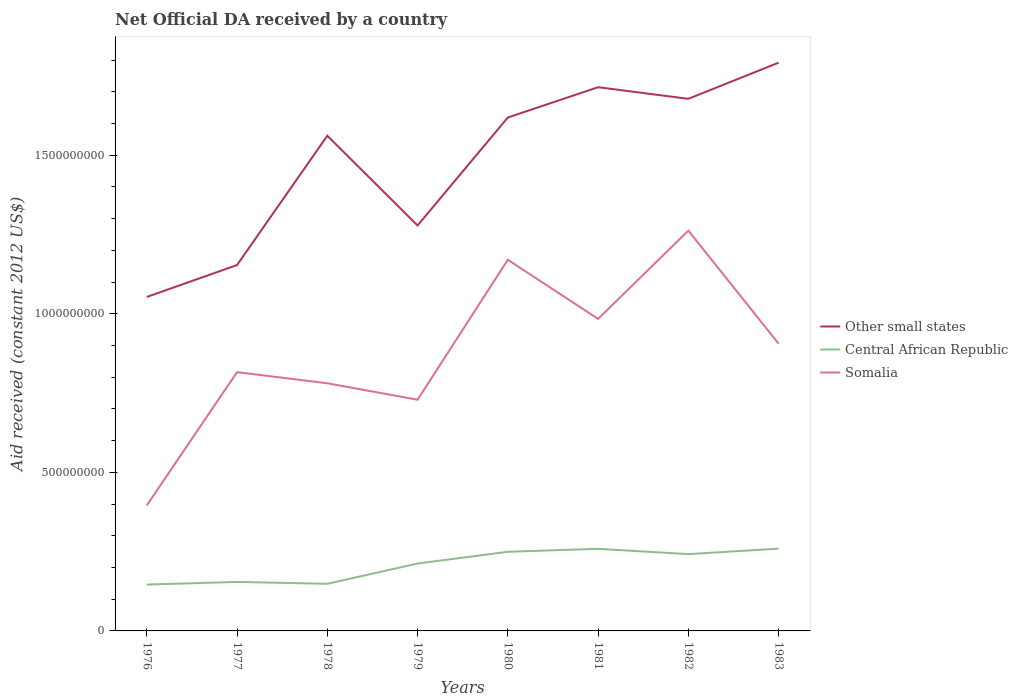Does the line corresponding to Somalia intersect with the line corresponding to Central African Republic?
Keep it short and to the point. No. Is the number of lines equal to the number of legend labels?
Make the answer very short. Yes. Across all years, what is the maximum net official development assistance aid received in Other small states?
Make the answer very short. 1.05e+09. In which year was the net official development assistance aid received in Somalia maximum?
Offer a very short reply. 1976. What is the total net official development assistance aid received in Somalia in the graph?
Offer a very short reply. -4.20e+08. What is the difference between the highest and the second highest net official development assistance aid received in Somalia?
Your answer should be very brief. 8.66e+08. What is the difference between the highest and the lowest net official development assistance aid received in Other small states?
Give a very brief answer. 5. Is the net official development assistance aid received in Somalia strictly greater than the net official development assistance aid received in Central African Republic over the years?
Your response must be concise. No. How many years are there in the graph?
Provide a succinct answer. 8. What is the difference between two consecutive major ticks on the Y-axis?
Offer a terse response. 5.00e+08. Are the values on the major ticks of Y-axis written in scientific E-notation?
Provide a short and direct response. No. Does the graph contain any zero values?
Provide a short and direct response. No. What is the title of the graph?
Provide a succinct answer. Net Official DA received by a country. What is the label or title of the Y-axis?
Give a very brief answer. Aid received (constant 2012 US$). What is the Aid received (constant 2012 US$) in Other small states in 1976?
Provide a succinct answer. 1.05e+09. What is the Aid received (constant 2012 US$) in Central African Republic in 1976?
Offer a terse response. 1.46e+08. What is the Aid received (constant 2012 US$) of Somalia in 1976?
Offer a terse response. 3.96e+08. What is the Aid received (constant 2012 US$) of Other small states in 1977?
Give a very brief answer. 1.15e+09. What is the Aid received (constant 2012 US$) in Central African Republic in 1977?
Give a very brief answer. 1.54e+08. What is the Aid received (constant 2012 US$) in Somalia in 1977?
Keep it short and to the point. 8.16e+08. What is the Aid received (constant 2012 US$) in Other small states in 1978?
Give a very brief answer. 1.56e+09. What is the Aid received (constant 2012 US$) of Central African Republic in 1978?
Provide a short and direct response. 1.49e+08. What is the Aid received (constant 2012 US$) in Somalia in 1978?
Give a very brief answer. 7.81e+08. What is the Aid received (constant 2012 US$) of Other small states in 1979?
Provide a short and direct response. 1.28e+09. What is the Aid received (constant 2012 US$) of Central African Republic in 1979?
Give a very brief answer. 2.12e+08. What is the Aid received (constant 2012 US$) of Somalia in 1979?
Provide a short and direct response. 7.29e+08. What is the Aid received (constant 2012 US$) in Other small states in 1980?
Offer a terse response. 1.62e+09. What is the Aid received (constant 2012 US$) of Central African Republic in 1980?
Your answer should be compact. 2.50e+08. What is the Aid received (constant 2012 US$) of Somalia in 1980?
Keep it short and to the point. 1.17e+09. What is the Aid received (constant 2012 US$) in Other small states in 1981?
Provide a short and direct response. 1.71e+09. What is the Aid received (constant 2012 US$) in Central African Republic in 1981?
Your answer should be very brief. 2.59e+08. What is the Aid received (constant 2012 US$) of Somalia in 1981?
Your answer should be very brief. 9.84e+08. What is the Aid received (constant 2012 US$) in Other small states in 1982?
Your answer should be compact. 1.68e+09. What is the Aid received (constant 2012 US$) of Central African Republic in 1982?
Offer a terse response. 2.42e+08. What is the Aid received (constant 2012 US$) in Somalia in 1982?
Offer a very short reply. 1.26e+09. What is the Aid received (constant 2012 US$) in Other small states in 1983?
Ensure brevity in your answer.  1.79e+09. What is the Aid received (constant 2012 US$) in Central African Republic in 1983?
Provide a succinct answer. 2.59e+08. What is the Aid received (constant 2012 US$) in Somalia in 1983?
Offer a very short reply. 9.06e+08. Across all years, what is the maximum Aid received (constant 2012 US$) of Other small states?
Make the answer very short. 1.79e+09. Across all years, what is the maximum Aid received (constant 2012 US$) in Central African Republic?
Your answer should be very brief. 2.59e+08. Across all years, what is the maximum Aid received (constant 2012 US$) in Somalia?
Make the answer very short. 1.26e+09. Across all years, what is the minimum Aid received (constant 2012 US$) of Other small states?
Your response must be concise. 1.05e+09. Across all years, what is the minimum Aid received (constant 2012 US$) of Central African Republic?
Offer a very short reply. 1.46e+08. Across all years, what is the minimum Aid received (constant 2012 US$) in Somalia?
Offer a terse response. 3.96e+08. What is the total Aid received (constant 2012 US$) in Other small states in the graph?
Keep it short and to the point. 1.18e+1. What is the total Aid received (constant 2012 US$) in Central African Republic in the graph?
Offer a terse response. 1.67e+09. What is the total Aid received (constant 2012 US$) of Somalia in the graph?
Provide a short and direct response. 7.04e+09. What is the difference between the Aid received (constant 2012 US$) of Other small states in 1976 and that in 1977?
Your answer should be very brief. -1.00e+08. What is the difference between the Aid received (constant 2012 US$) in Central African Republic in 1976 and that in 1977?
Provide a succinct answer. -8.35e+06. What is the difference between the Aid received (constant 2012 US$) of Somalia in 1976 and that in 1977?
Make the answer very short. -4.20e+08. What is the difference between the Aid received (constant 2012 US$) in Other small states in 1976 and that in 1978?
Your answer should be very brief. -5.08e+08. What is the difference between the Aid received (constant 2012 US$) of Central African Republic in 1976 and that in 1978?
Give a very brief answer. -2.46e+06. What is the difference between the Aid received (constant 2012 US$) of Somalia in 1976 and that in 1978?
Keep it short and to the point. -3.85e+08. What is the difference between the Aid received (constant 2012 US$) of Other small states in 1976 and that in 1979?
Keep it short and to the point. -2.25e+08. What is the difference between the Aid received (constant 2012 US$) of Central African Republic in 1976 and that in 1979?
Your answer should be very brief. -6.63e+07. What is the difference between the Aid received (constant 2012 US$) in Somalia in 1976 and that in 1979?
Offer a very short reply. -3.33e+08. What is the difference between the Aid received (constant 2012 US$) of Other small states in 1976 and that in 1980?
Make the answer very short. -5.66e+08. What is the difference between the Aid received (constant 2012 US$) in Central African Republic in 1976 and that in 1980?
Keep it short and to the point. -1.03e+08. What is the difference between the Aid received (constant 2012 US$) of Somalia in 1976 and that in 1980?
Provide a short and direct response. -7.75e+08. What is the difference between the Aid received (constant 2012 US$) in Other small states in 1976 and that in 1981?
Provide a short and direct response. -6.61e+08. What is the difference between the Aid received (constant 2012 US$) in Central African Republic in 1976 and that in 1981?
Your answer should be very brief. -1.13e+08. What is the difference between the Aid received (constant 2012 US$) of Somalia in 1976 and that in 1981?
Provide a short and direct response. -5.88e+08. What is the difference between the Aid received (constant 2012 US$) in Other small states in 1976 and that in 1982?
Your response must be concise. -6.25e+08. What is the difference between the Aid received (constant 2012 US$) of Central African Republic in 1976 and that in 1982?
Your answer should be very brief. -9.60e+07. What is the difference between the Aid received (constant 2012 US$) of Somalia in 1976 and that in 1982?
Offer a terse response. -8.66e+08. What is the difference between the Aid received (constant 2012 US$) of Other small states in 1976 and that in 1983?
Ensure brevity in your answer.  -7.39e+08. What is the difference between the Aid received (constant 2012 US$) of Central African Republic in 1976 and that in 1983?
Your answer should be very brief. -1.13e+08. What is the difference between the Aid received (constant 2012 US$) of Somalia in 1976 and that in 1983?
Provide a short and direct response. -5.10e+08. What is the difference between the Aid received (constant 2012 US$) in Other small states in 1977 and that in 1978?
Your answer should be compact. -4.08e+08. What is the difference between the Aid received (constant 2012 US$) of Central African Republic in 1977 and that in 1978?
Make the answer very short. 5.89e+06. What is the difference between the Aid received (constant 2012 US$) of Somalia in 1977 and that in 1978?
Make the answer very short. 3.50e+07. What is the difference between the Aid received (constant 2012 US$) in Other small states in 1977 and that in 1979?
Your answer should be very brief. -1.25e+08. What is the difference between the Aid received (constant 2012 US$) of Central African Republic in 1977 and that in 1979?
Your answer should be compact. -5.80e+07. What is the difference between the Aid received (constant 2012 US$) in Somalia in 1977 and that in 1979?
Make the answer very short. 8.69e+07. What is the difference between the Aid received (constant 2012 US$) of Other small states in 1977 and that in 1980?
Your answer should be very brief. -4.65e+08. What is the difference between the Aid received (constant 2012 US$) in Central African Republic in 1977 and that in 1980?
Your response must be concise. -9.50e+07. What is the difference between the Aid received (constant 2012 US$) of Somalia in 1977 and that in 1980?
Your response must be concise. -3.54e+08. What is the difference between the Aid received (constant 2012 US$) of Other small states in 1977 and that in 1981?
Offer a very short reply. -5.61e+08. What is the difference between the Aid received (constant 2012 US$) in Central African Republic in 1977 and that in 1981?
Ensure brevity in your answer.  -1.04e+08. What is the difference between the Aid received (constant 2012 US$) in Somalia in 1977 and that in 1981?
Keep it short and to the point. -1.68e+08. What is the difference between the Aid received (constant 2012 US$) in Other small states in 1977 and that in 1982?
Your answer should be very brief. -5.24e+08. What is the difference between the Aid received (constant 2012 US$) in Central African Republic in 1977 and that in 1982?
Your answer should be compact. -8.76e+07. What is the difference between the Aid received (constant 2012 US$) of Somalia in 1977 and that in 1982?
Keep it short and to the point. -4.46e+08. What is the difference between the Aid received (constant 2012 US$) of Other small states in 1977 and that in 1983?
Provide a short and direct response. -6.38e+08. What is the difference between the Aid received (constant 2012 US$) in Central African Republic in 1977 and that in 1983?
Make the answer very short. -1.05e+08. What is the difference between the Aid received (constant 2012 US$) in Somalia in 1977 and that in 1983?
Your response must be concise. -8.97e+07. What is the difference between the Aid received (constant 2012 US$) in Other small states in 1978 and that in 1979?
Make the answer very short. 2.83e+08. What is the difference between the Aid received (constant 2012 US$) of Central African Republic in 1978 and that in 1979?
Offer a very short reply. -6.39e+07. What is the difference between the Aid received (constant 2012 US$) of Somalia in 1978 and that in 1979?
Provide a succinct answer. 5.19e+07. What is the difference between the Aid received (constant 2012 US$) in Other small states in 1978 and that in 1980?
Keep it short and to the point. -5.75e+07. What is the difference between the Aid received (constant 2012 US$) of Central African Republic in 1978 and that in 1980?
Ensure brevity in your answer.  -1.01e+08. What is the difference between the Aid received (constant 2012 US$) in Somalia in 1978 and that in 1980?
Provide a succinct answer. -3.89e+08. What is the difference between the Aid received (constant 2012 US$) of Other small states in 1978 and that in 1981?
Offer a terse response. -1.53e+08. What is the difference between the Aid received (constant 2012 US$) of Central African Republic in 1978 and that in 1981?
Offer a terse response. -1.10e+08. What is the difference between the Aid received (constant 2012 US$) of Somalia in 1978 and that in 1981?
Offer a very short reply. -2.03e+08. What is the difference between the Aid received (constant 2012 US$) of Other small states in 1978 and that in 1982?
Keep it short and to the point. -1.16e+08. What is the difference between the Aid received (constant 2012 US$) in Central African Republic in 1978 and that in 1982?
Your answer should be compact. -9.35e+07. What is the difference between the Aid received (constant 2012 US$) of Somalia in 1978 and that in 1982?
Offer a very short reply. -4.81e+08. What is the difference between the Aid received (constant 2012 US$) in Other small states in 1978 and that in 1983?
Offer a terse response. -2.30e+08. What is the difference between the Aid received (constant 2012 US$) of Central African Republic in 1978 and that in 1983?
Provide a succinct answer. -1.11e+08. What is the difference between the Aid received (constant 2012 US$) of Somalia in 1978 and that in 1983?
Your answer should be very brief. -1.25e+08. What is the difference between the Aid received (constant 2012 US$) of Other small states in 1979 and that in 1980?
Make the answer very short. -3.40e+08. What is the difference between the Aid received (constant 2012 US$) in Central African Republic in 1979 and that in 1980?
Ensure brevity in your answer.  -3.70e+07. What is the difference between the Aid received (constant 2012 US$) in Somalia in 1979 and that in 1980?
Your answer should be compact. -4.41e+08. What is the difference between the Aid received (constant 2012 US$) in Other small states in 1979 and that in 1981?
Provide a succinct answer. -4.36e+08. What is the difference between the Aid received (constant 2012 US$) of Central African Republic in 1979 and that in 1981?
Give a very brief answer. -4.64e+07. What is the difference between the Aid received (constant 2012 US$) in Somalia in 1979 and that in 1981?
Your response must be concise. -2.55e+08. What is the difference between the Aid received (constant 2012 US$) of Other small states in 1979 and that in 1982?
Make the answer very short. -3.99e+08. What is the difference between the Aid received (constant 2012 US$) in Central African Republic in 1979 and that in 1982?
Your response must be concise. -2.96e+07. What is the difference between the Aid received (constant 2012 US$) in Somalia in 1979 and that in 1982?
Your answer should be compact. -5.33e+08. What is the difference between the Aid received (constant 2012 US$) of Other small states in 1979 and that in 1983?
Offer a terse response. -5.13e+08. What is the difference between the Aid received (constant 2012 US$) in Central African Republic in 1979 and that in 1983?
Provide a succinct answer. -4.69e+07. What is the difference between the Aid received (constant 2012 US$) in Somalia in 1979 and that in 1983?
Provide a short and direct response. -1.77e+08. What is the difference between the Aid received (constant 2012 US$) of Other small states in 1980 and that in 1981?
Your answer should be compact. -9.55e+07. What is the difference between the Aid received (constant 2012 US$) in Central African Republic in 1980 and that in 1981?
Your answer should be very brief. -9.37e+06. What is the difference between the Aid received (constant 2012 US$) in Somalia in 1980 and that in 1981?
Your answer should be compact. 1.87e+08. What is the difference between the Aid received (constant 2012 US$) in Other small states in 1980 and that in 1982?
Offer a very short reply. -5.89e+07. What is the difference between the Aid received (constant 2012 US$) in Central African Republic in 1980 and that in 1982?
Your answer should be very brief. 7.39e+06. What is the difference between the Aid received (constant 2012 US$) in Somalia in 1980 and that in 1982?
Ensure brevity in your answer.  -9.18e+07. What is the difference between the Aid received (constant 2012 US$) of Other small states in 1980 and that in 1983?
Provide a short and direct response. -1.73e+08. What is the difference between the Aid received (constant 2012 US$) of Central African Republic in 1980 and that in 1983?
Provide a succinct answer. -9.90e+06. What is the difference between the Aid received (constant 2012 US$) of Somalia in 1980 and that in 1983?
Your response must be concise. 2.65e+08. What is the difference between the Aid received (constant 2012 US$) of Other small states in 1981 and that in 1982?
Provide a succinct answer. 3.66e+07. What is the difference between the Aid received (constant 2012 US$) in Central African Republic in 1981 and that in 1982?
Make the answer very short. 1.68e+07. What is the difference between the Aid received (constant 2012 US$) in Somalia in 1981 and that in 1982?
Your answer should be compact. -2.78e+08. What is the difference between the Aid received (constant 2012 US$) of Other small states in 1981 and that in 1983?
Make the answer very short. -7.74e+07. What is the difference between the Aid received (constant 2012 US$) in Central African Republic in 1981 and that in 1983?
Provide a short and direct response. -5.30e+05. What is the difference between the Aid received (constant 2012 US$) of Somalia in 1981 and that in 1983?
Your response must be concise. 7.82e+07. What is the difference between the Aid received (constant 2012 US$) in Other small states in 1982 and that in 1983?
Your response must be concise. -1.14e+08. What is the difference between the Aid received (constant 2012 US$) in Central African Republic in 1982 and that in 1983?
Ensure brevity in your answer.  -1.73e+07. What is the difference between the Aid received (constant 2012 US$) of Somalia in 1982 and that in 1983?
Offer a very short reply. 3.57e+08. What is the difference between the Aid received (constant 2012 US$) of Other small states in 1976 and the Aid received (constant 2012 US$) of Central African Republic in 1977?
Make the answer very short. 8.99e+08. What is the difference between the Aid received (constant 2012 US$) of Other small states in 1976 and the Aid received (constant 2012 US$) of Somalia in 1977?
Ensure brevity in your answer.  2.37e+08. What is the difference between the Aid received (constant 2012 US$) of Central African Republic in 1976 and the Aid received (constant 2012 US$) of Somalia in 1977?
Provide a short and direct response. -6.70e+08. What is the difference between the Aid received (constant 2012 US$) of Other small states in 1976 and the Aid received (constant 2012 US$) of Central African Republic in 1978?
Keep it short and to the point. 9.04e+08. What is the difference between the Aid received (constant 2012 US$) in Other small states in 1976 and the Aid received (constant 2012 US$) in Somalia in 1978?
Your answer should be compact. 2.72e+08. What is the difference between the Aid received (constant 2012 US$) in Central African Republic in 1976 and the Aid received (constant 2012 US$) in Somalia in 1978?
Keep it short and to the point. -6.35e+08. What is the difference between the Aid received (constant 2012 US$) in Other small states in 1976 and the Aid received (constant 2012 US$) in Central African Republic in 1979?
Keep it short and to the point. 8.41e+08. What is the difference between the Aid received (constant 2012 US$) in Other small states in 1976 and the Aid received (constant 2012 US$) in Somalia in 1979?
Give a very brief answer. 3.24e+08. What is the difference between the Aid received (constant 2012 US$) of Central African Republic in 1976 and the Aid received (constant 2012 US$) of Somalia in 1979?
Your answer should be compact. -5.83e+08. What is the difference between the Aid received (constant 2012 US$) in Other small states in 1976 and the Aid received (constant 2012 US$) in Central African Republic in 1980?
Your response must be concise. 8.04e+08. What is the difference between the Aid received (constant 2012 US$) in Other small states in 1976 and the Aid received (constant 2012 US$) in Somalia in 1980?
Ensure brevity in your answer.  -1.17e+08. What is the difference between the Aid received (constant 2012 US$) of Central African Republic in 1976 and the Aid received (constant 2012 US$) of Somalia in 1980?
Make the answer very short. -1.02e+09. What is the difference between the Aid received (constant 2012 US$) of Other small states in 1976 and the Aid received (constant 2012 US$) of Central African Republic in 1981?
Provide a succinct answer. 7.94e+08. What is the difference between the Aid received (constant 2012 US$) of Other small states in 1976 and the Aid received (constant 2012 US$) of Somalia in 1981?
Keep it short and to the point. 6.92e+07. What is the difference between the Aid received (constant 2012 US$) of Central African Republic in 1976 and the Aid received (constant 2012 US$) of Somalia in 1981?
Your answer should be compact. -8.38e+08. What is the difference between the Aid received (constant 2012 US$) in Other small states in 1976 and the Aid received (constant 2012 US$) in Central African Republic in 1982?
Make the answer very short. 8.11e+08. What is the difference between the Aid received (constant 2012 US$) of Other small states in 1976 and the Aid received (constant 2012 US$) of Somalia in 1982?
Provide a succinct answer. -2.09e+08. What is the difference between the Aid received (constant 2012 US$) of Central African Republic in 1976 and the Aid received (constant 2012 US$) of Somalia in 1982?
Offer a terse response. -1.12e+09. What is the difference between the Aid received (constant 2012 US$) in Other small states in 1976 and the Aid received (constant 2012 US$) in Central African Republic in 1983?
Provide a succinct answer. 7.94e+08. What is the difference between the Aid received (constant 2012 US$) of Other small states in 1976 and the Aid received (constant 2012 US$) of Somalia in 1983?
Offer a terse response. 1.47e+08. What is the difference between the Aid received (constant 2012 US$) in Central African Republic in 1976 and the Aid received (constant 2012 US$) in Somalia in 1983?
Ensure brevity in your answer.  -7.59e+08. What is the difference between the Aid received (constant 2012 US$) in Other small states in 1977 and the Aid received (constant 2012 US$) in Central African Republic in 1978?
Your answer should be compact. 1.00e+09. What is the difference between the Aid received (constant 2012 US$) of Other small states in 1977 and the Aid received (constant 2012 US$) of Somalia in 1978?
Your answer should be very brief. 3.73e+08. What is the difference between the Aid received (constant 2012 US$) in Central African Republic in 1977 and the Aid received (constant 2012 US$) in Somalia in 1978?
Make the answer very short. -6.26e+08. What is the difference between the Aid received (constant 2012 US$) in Other small states in 1977 and the Aid received (constant 2012 US$) in Central African Republic in 1979?
Give a very brief answer. 9.41e+08. What is the difference between the Aid received (constant 2012 US$) of Other small states in 1977 and the Aid received (constant 2012 US$) of Somalia in 1979?
Offer a very short reply. 4.25e+08. What is the difference between the Aid received (constant 2012 US$) of Central African Republic in 1977 and the Aid received (constant 2012 US$) of Somalia in 1979?
Your answer should be very brief. -5.74e+08. What is the difference between the Aid received (constant 2012 US$) in Other small states in 1977 and the Aid received (constant 2012 US$) in Central African Republic in 1980?
Ensure brevity in your answer.  9.04e+08. What is the difference between the Aid received (constant 2012 US$) in Other small states in 1977 and the Aid received (constant 2012 US$) in Somalia in 1980?
Your answer should be compact. -1.68e+07. What is the difference between the Aid received (constant 2012 US$) in Central African Republic in 1977 and the Aid received (constant 2012 US$) in Somalia in 1980?
Your answer should be compact. -1.02e+09. What is the difference between the Aid received (constant 2012 US$) in Other small states in 1977 and the Aid received (constant 2012 US$) in Central African Republic in 1981?
Keep it short and to the point. 8.95e+08. What is the difference between the Aid received (constant 2012 US$) of Other small states in 1977 and the Aid received (constant 2012 US$) of Somalia in 1981?
Give a very brief answer. 1.70e+08. What is the difference between the Aid received (constant 2012 US$) in Central African Republic in 1977 and the Aid received (constant 2012 US$) in Somalia in 1981?
Ensure brevity in your answer.  -8.29e+08. What is the difference between the Aid received (constant 2012 US$) of Other small states in 1977 and the Aid received (constant 2012 US$) of Central African Republic in 1982?
Your answer should be very brief. 9.11e+08. What is the difference between the Aid received (constant 2012 US$) in Other small states in 1977 and the Aid received (constant 2012 US$) in Somalia in 1982?
Your answer should be very brief. -1.09e+08. What is the difference between the Aid received (constant 2012 US$) of Central African Republic in 1977 and the Aid received (constant 2012 US$) of Somalia in 1982?
Offer a very short reply. -1.11e+09. What is the difference between the Aid received (constant 2012 US$) of Other small states in 1977 and the Aid received (constant 2012 US$) of Central African Republic in 1983?
Offer a very short reply. 8.94e+08. What is the difference between the Aid received (constant 2012 US$) in Other small states in 1977 and the Aid received (constant 2012 US$) in Somalia in 1983?
Ensure brevity in your answer.  2.48e+08. What is the difference between the Aid received (constant 2012 US$) of Central African Republic in 1977 and the Aid received (constant 2012 US$) of Somalia in 1983?
Offer a very short reply. -7.51e+08. What is the difference between the Aid received (constant 2012 US$) of Other small states in 1978 and the Aid received (constant 2012 US$) of Central African Republic in 1979?
Ensure brevity in your answer.  1.35e+09. What is the difference between the Aid received (constant 2012 US$) in Other small states in 1978 and the Aid received (constant 2012 US$) in Somalia in 1979?
Give a very brief answer. 8.32e+08. What is the difference between the Aid received (constant 2012 US$) in Central African Republic in 1978 and the Aid received (constant 2012 US$) in Somalia in 1979?
Offer a terse response. -5.80e+08. What is the difference between the Aid received (constant 2012 US$) in Other small states in 1978 and the Aid received (constant 2012 US$) in Central African Republic in 1980?
Offer a very short reply. 1.31e+09. What is the difference between the Aid received (constant 2012 US$) of Other small states in 1978 and the Aid received (constant 2012 US$) of Somalia in 1980?
Give a very brief answer. 3.91e+08. What is the difference between the Aid received (constant 2012 US$) of Central African Republic in 1978 and the Aid received (constant 2012 US$) of Somalia in 1980?
Your answer should be very brief. -1.02e+09. What is the difference between the Aid received (constant 2012 US$) in Other small states in 1978 and the Aid received (constant 2012 US$) in Central African Republic in 1981?
Offer a terse response. 1.30e+09. What is the difference between the Aid received (constant 2012 US$) in Other small states in 1978 and the Aid received (constant 2012 US$) in Somalia in 1981?
Your answer should be very brief. 5.78e+08. What is the difference between the Aid received (constant 2012 US$) of Central African Republic in 1978 and the Aid received (constant 2012 US$) of Somalia in 1981?
Give a very brief answer. -8.35e+08. What is the difference between the Aid received (constant 2012 US$) of Other small states in 1978 and the Aid received (constant 2012 US$) of Central African Republic in 1982?
Your answer should be compact. 1.32e+09. What is the difference between the Aid received (constant 2012 US$) in Other small states in 1978 and the Aid received (constant 2012 US$) in Somalia in 1982?
Your answer should be compact. 2.99e+08. What is the difference between the Aid received (constant 2012 US$) in Central African Republic in 1978 and the Aid received (constant 2012 US$) in Somalia in 1982?
Keep it short and to the point. -1.11e+09. What is the difference between the Aid received (constant 2012 US$) of Other small states in 1978 and the Aid received (constant 2012 US$) of Central African Republic in 1983?
Keep it short and to the point. 1.30e+09. What is the difference between the Aid received (constant 2012 US$) of Other small states in 1978 and the Aid received (constant 2012 US$) of Somalia in 1983?
Your answer should be very brief. 6.56e+08. What is the difference between the Aid received (constant 2012 US$) in Central African Republic in 1978 and the Aid received (constant 2012 US$) in Somalia in 1983?
Keep it short and to the point. -7.57e+08. What is the difference between the Aid received (constant 2012 US$) in Other small states in 1979 and the Aid received (constant 2012 US$) in Central African Republic in 1980?
Make the answer very short. 1.03e+09. What is the difference between the Aid received (constant 2012 US$) in Other small states in 1979 and the Aid received (constant 2012 US$) in Somalia in 1980?
Provide a succinct answer. 1.08e+08. What is the difference between the Aid received (constant 2012 US$) of Central African Republic in 1979 and the Aid received (constant 2012 US$) of Somalia in 1980?
Give a very brief answer. -9.58e+08. What is the difference between the Aid received (constant 2012 US$) in Other small states in 1979 and the Aid received (constant 2012 US$) in Central African Republic in 1981?
Provide a succinct answer. 1.02e+09. What is the difference between the Aid received (constant 2012 US$) in Other small states in 1979 and the Aid received (constant 2012 US$) in Somalia in 1981?
Keep it short and to the point. 2.95e+08. What is the difference between the Aid received (constant 2012 US$) of Central African Republic in 1979 and the Aid received (constant 2012 US$) of Somalia in 1981?
Offer a very short reply. -7.71e+08. What is the difference between the Aid received (constant 2012 US$) of Other small states in 1979 and the Aid received (constant 2012 US$) of Central African Republic in 1982?
Provide a succinct answer. 1.04e+09. What is the difference between the Aid received (constant 2012 US$) in Other small states in 1979 and the Aid received (constant 2012 US$) in Somalia in 1982?
Ensure brevity in your answer.  1.63e+07. What is the difference between the Aid received (constant 2012 US$) in Central African Republic in 1979 and the Aid received (constant 2012 US$) in Somalia in 1982?
Keep it short and to the point. -1.05e+09. What is the difference between the Aid received (constant 2012 US$) of Other small states in 1979 and the Aid received (constant 2012 US$) of Central African Republic in 1983?
Offer a terse response. 1.02e+09. What is the difference between the Aid received (constant 2012 US$) of Other small states in 1979 and the Aid received (constant 2012 US$) of Somalia in 1983?
Your response must be concise. 3.73e+08. What is the difference between the Aid received (constant 2012 US$) of Central African Republic in 1979 and the Aid received (constant 2012 US$) of Somalia in 1983?
Keep it short and to the point. -6.93e+08. What is the difference between the Aid received (constant 2012 US$) in Other small states in 1980 and the Aid received (constant 2012 US$) in Central African Republic in 1981?
Give a very brief answer. 1.36e+09. What is the difference between the Aid received (constant 2012 US$) in Other small states in 1980 and the Aid received (constant 2012 US$) in Somalia in 1981?
Offer a terse response. 6.35e+08. What is the difference between the Aid received (constant 2012 US$) in Central African Republic in 1980 and the Aid received (constant 2012 US$) in Somalia in 1981?
Make the answer very short. -7.34e+08. What is the difference between the Aid received (constant 2012 US$) in Other small states in 1980 and the Aid received (constant 2012 US$) in Central African Republic in 1982?
Your answer should be compact. 1.38e+09. What is the difference between the Aid received (constant 2012 US$) of Other small states in 1980 and the Aid received (constant 2012 US$) of Somalia in 1982?
Provide a succinct answer. 3.57e+08. What is the difference between the Aid received (constant 2012 US$) of Central African Republic in 1980 and the Aid received (constant 2012 US$) of Somalia in 1982?
Keep it short and to the point. -1.01e+09. What is the difference between the Aid received (constant 2012 US$) of Other small states in 1980 and the Aid received (constant 2012 US$) of Central African Republic in 1983?
Provide a succinct answer. 1.36e+09. What is the difference between the Aid received (constant 2012 US$) in Other small states in 1980 and the Aid received (constant 2012 US$) in Somalia in 1983?
Offer a very short reply. 7.13e+08. What is the difference between the Aid received (constant 2012 US$) of Central African Republic in 1980 and the Aid received (constant 2012 US$) of Somalia in 1983?
Offer a terse response. -6.56e+08. What is the difference between the Aid received (constant 2012 US$) of Other small states in 1981 and the Aid received (constant 2012 US$) of Central African Republic in 1982?
Your answer should be compact. 1.47e+09. What is the difference between the Aid received (constant 2012 US$) in Other small states in 1981 and the Aid received (constant 2012 US$) in Somalia in 1982?
Ensure brevity in your answer.  4.52e+08. What is the difference between the Aid received (constant 2012 US$) of Central African Republic in 1981 and the Aid received (constant 2012 US$) of Somalia in 1982?
Give a very brief answer. -1.00e+09. What is the difference between the Aid received (constant 2012 US$) in Other small states in 1981 and the Aid received (constant 2012 US$) in Central African Republic in 1983?
Your answer should be very brief. 1.45e+09. What is the difference between the Aid received (constant 2012 US$) in Other small states in 1981 and the Aid received (constant 2012 US$) in Somalia in 1983?
Keep it short and to the point. 8.09e+08. What is the difference between the Aid received (constant 2012 US$) in Central African Republic in 1981 and the Aid received (constant 2012 US$) in Somalia in 1983?
Your answer should be compact. -6.47e+08. What is the difference between the Aid received (constant 2012 US$) of Other small states in 1982 and the Aid received (constant 2012 US$) of Central African Republic in 1983?
Make the answer very short. 1.42e+09. What is the difference between the Aid received (constant 2012 US$) in Other small states in 1982 and the Aid received (constant 2012 US$) in Somalia in 1983?
Make the answer very short. 7.72e+08. What is the difference between the Aid received (constant 2012 US$) in Central African Republic in 1982 and the Aid received (constant 2012 US$) in Somalia in 1983?
Make the answer very short. -6.63e+08. What is the average Aid received (constant 2012 US$) in Other small states per year?
Ensure brevity in your answer.  1.48e+09. What is the average Aid received (constant 2012 US$) in Central African Republic per year?
Your response must be concise. 2.09e+08. What is the average Aid received (constant 2012 US$) in Somalia per year?
Provide a succinct answer. 8.80e+08. In the year 1976, what is the difference between the Aid received (constant 2012 US$) of Other small states and Aid received (constant 2012 US$) of Central African Republic?
Offer a terse response. 9.07e+08. In the year 1976, what is the difference between the Aid received (constant 2012 US$) of Other small states and Aid received (constant 2012 US$) of Somalia?
Keep it short and to the point. 6.57e+08. In the year 1976, what is the difference between the Aid received (constant 2012 US$) of Central African Republic and Aid received (constant 2012 US$) of Somalia?
Give a very brief answer. -2.50e+08. In the year 1977, what is the difference between the Aid received (constant 2012 US$) in Other small states and Aid received (constant 2012 US$) in Central African Republic?
Provide a succinct answer. 9.99e+08. In the year 1977, what is the difference between the Aid received (constant 2012 US$) in Other small states and Aid received (constant 2012 US$) in Somalia?
Keep it short and to the point. 3.38e+08. In the year 1977, what is the difference between the Aid received (constant 2012 US$) of Central African Republic and Aid received (constant 2012 US$) of Somalia?
Make the answer very short. -6.61e+08. In the year 1978, what is the difference between the Aid received (constant 2012 US$) in Other small states and Aid received (constant 2012 US$) in Central African Republic?
Your answer should be very brief. 1.41e+09. In the year 1978, what is the difference between the Aid received (constant 2012 US$) of Other small states and Aid received (constant 2012 US$) of Somalia?
Your answer should be very brief. 7.80e+08. In the year 1978, what is the difference between the Aid received (constant 2012 US$) in Central African Republic and Aid received (constant 2012 US$) in Somalia?
Offer a terse response. -6.32e+08. In the year 1979, what is the difference between the Aid received (constant 2012 US$) in Other small states and Aid received (constant 2012 US$) in Central African Republic?
Your answer should be compact. 1.07e+09. In the year 1979, what is the difference between the Aid received (constant 2012 US$) of Other small states and Aid received (constant 2012 US$) of Somalia?
Your answer should be very brief. 5.49e+08. In the year 1979, what is the difference between the Aid received (constant 2012 US$) of Central African Republic and Aid received (constant 2012 US$) of Somalia?
Give a very brief answer. -5.16e+08. In the year 1980, what is the difference between the Aid received (constant 2012 US$) in Other small states and Aid received (constant 2012 US$) in Central African Republic?
Your answer should be very brief. 1.37e+09. In the year 1980, what is the difference between the Aid received (constant 2012 US$) in Other small states and Aid received (constant 2012 US$) in Somalia?
Your answer should be compact. 4.49e+08. In the year 1980, what is the difference between the Aid received (constant 2012 US$) in Central African Republic and Aid received (constant 2012 US$) in Somalia?
Provide a short and direct response. -9.21e+08. In the year 1981, what is the difference between the Aid received (constant 2012 US$) in Other small states and Aid received (constant 2012 US$) in Central African Republic?
Provide a succinct answer. 1.46e+09. In the year 1981, what is the difference between the Aid received (constant 2012 US$) of Other small states and Aid received (constant 2012 US$) of Somalia?
Provide a short and direct response. 7.30e+08. In the year 1981, what is the difference between the Aid received (constant 2012 US$) of Central African Republic and Aid received (constant 2012 US$) of Somalia?
Offer a terse response. -7.25e+08. In the year 1982, what is the difference between the Aid received (constant 2012 US$) in Other small states and Aid received (constant 2012 US$) in Central African Republic?
Your response must be concise. 1.44e+09. In the year 1982, what is the difference between the Aid received (constant 2012 US$) in Other small states and Aid received (constant 2012 US$) in Somalia?
Offer a terse response. 4.16e+08. In the year 1982, what is the difference between the Aid received (constant 2012 US$) in Central African Republic and Aid received (constant 2012 US$) in Somalia?
Provide a short and direct response. -1.02e+09. In the year 1983, what is the difference between the Aid received (constant 2012 US$) of Other small states and Aid received (constant 2012 US$) of Central African Republic?
Your answer should be very brief. 1.53e+09. In the year 1983, what is the difference between the Aid received (constant 2012 US$) of Other small states and Aid received (constant 2012 US$) of Somalia?
Offer a terse response. 8.86e+08. In the year 1983, what is the difference between the Aid received (constant 2012 US$) of Central African Republic and Aid received (constant 2012 US$) of Somalia?
Offer a very short reply. -6.46e+08. What is the ratio of the Aid received (constant 2012 US$) of Other small states in 1976 to that in 1977?
Ensure brevity in your answer.  0.91. What is the ratio of the Aid received (constant 2012 US$) of Central African Republic in 1976 to that in 1977?
Offer a very short reply. 0.95. What is the ratio of the Aid received (constant 2012 US$) of Somalia in 1976 to that in 1977?
Offer a very short reply. 0.48. What is the ratio of the Aid received (constant 2012 US$) in Other small states in 1976 to that in 1978?
Provide a short and direct response. 0.67. What is the ratio of the Aid received (constant 2012 US$) in Central African Republic in 1976 to that in 1978?
Provide a short and direct response. 0.98. What is the ratio of the Aid received (constant 2012 US$) in Somalia in 1976 to that in 1978?
Your answer should be compact. 0.51. What is the ratio of the Aid received (constant 2012 US$) in Other small states in 1976 to that in 1979?
Your response must be concise. 0.82. What is the ratio of the Aid received (constant 2012 US$) in Central African Republic in 1976 to that in 1979?
Make the answer very short. 0.69. What is the ratio of the Aid received (constant 2012 US$) in Somalia in 1976 to that in 1979?
Keep it short and to the point. 0.54. What is the ratio of the Aid received (constant 2012 US$) in Other small states in 1976 to that in 1980?
Make the answer very short. 0.65. What is the ratio of the Aid received (constant 2012 US$) in Central African Republic in 1976 to that in 1980?
Provide a short and direct response. 0.59. What is the ratio of the Aid received (constant 2012 US$) in Somalia in 1976 to that in 1980?
Your response must be concise. 0.34. What is the ratio of the Aid received (constant 2012 US$) of Other small states in 1976 to that in 1981?
Your answer should be compact. 0.61. What is the ratio of the Aid received (constant 2012 US$) of Central African Republic in 1976 to that in 1981?
Your answer should be very brief. 0.56. What is the ratio of the Aid received (constant 2012 US$) in Somalia in 1976 to that in 1981?
Ensure brevity in your answer.  0.4. What is the ratio of the Aid received (constant 2012 US$) of Other small states in 1976 to that in 1982?
Provide a short and direct response. 0.63. What is the ratio of the Aid received (constant 2012 US$) of Central African Republic in 1976 to that in 1982?
Make the answer very short. 0.6. What is the ratio of the Aid received (constant 2012 US$) of Somalia in 1976 to that in 1982?
Your answer should be compact. 0.31. What is the ratio of the Aid received (constant 2012 US$) of Other small states in 1976 to that in 1983?
Your response must be concise. 0.59. What is the ratio of the Aid received (constant 2012 US$) of Central African Republic in 1976 to that in 1983?
Offer a terse response. 0.56. What is the ratio of the Aid received (constant 2012 US$) in Somalia in 1976 to that in 1983?
Provide a short and direct response. 0.44. What is the ratio of the Aid received (constant 2012 US$) in Other small states in 1977 to that in 1978?
Your answer should be compact. 0.74. What is the ratio of the Aid received (constant 2012 US$) of Central African Republic in 1977 to that in 1978?
Provide a succinct answer. 1.04. What is the ratio of the Aid received (constant 2012 US$) of Somalia in 1977 to that in 1978?
Your answer should be very brief. 1.04. What is the ratio of the Aid received (constant 2012 US$) in Other small states in 1977 to that in 1979?
Your answer should be very brief. 0.9. What is the ratio of the Aid received (constant 2012 US$) in Central African Republic in 1977 to that in 1979?
Ensure brevity in your answer.  0.73. What is the ratio of the Aid received (constant 2012 US$) in Somalia in 1977 to that in 1979?
Your answer should be compact. 1.12. What is the ratio of the Aid received (constant 2012 US$) of Other small states in 1977 to that in 1980?
Your answer should be compact. 0.71. What is the ratio of the Aid received (constant 2012 US$) in Central African Republic in 1977 to that in 1980?
Make the answer very short. 0.62. What is the ratio of the Aid received (constant 2012 US$) in Somalia in 1977 to that in 1980?
Offer a terse response. 0.7. What is the ratio of the Aid received (constant 2012 US$) of Other small states in 1977 to that in 1981?
Provide a short and direct response. 0.67. What is the ratio of the Aid received (constant 2012 US$) of Central African Republic in 1977 to that in 1981?
Offer a terse response. 0.6. What is the ratio of the Aid received (constant 2012 US$) of Somalia in 1977 to that in 1981?
Ensure brevity in your answer.  0.83. What is the ratio of the Aid received (constant 2012 US$) in Other small states in 1977 to that in 1982?
Offer a terse response. 0.69. What is the ratio of the Aid received (constant 2012 US$) of Central African Republic in 1977 to that in 1982?
Make the answer very short. 0.64. What is the ratio of the Aid received (constant 2012 US$) of Somalia in 1977 to that in 1982?
Make the answer very short. 0.65. What is the ratio of the Aid received (constant 2012 US$) in Other small states in 1977 to that in 1983?
Your answer should be compact. 0.64. What is the ratio of the Aid received (constant 2012 US$) in Central African Republic in 1977 to that in 1983?
Your answer should be compact. 0.6. What is the ratio of the Aid received (constant 2012 US$) of Somalia in 1977 to that in 1983?
Give a very brief answer. 0.9. What is the ratio of the Aid received (constant 2012 US$) of Other small states in 1978 to that in 1979?
Keep it short and to the point. 1.22. What is the ratio of the Aid received (constant 2012 US$) of Central African Republic in 1978 to that in 1979?
Your answer should be compact. 0.7. What is the ratio of the Aid received (constant 2012 US$) in Somalia in 1978 to that in 1979?
Offer a terse response. 1.07. What is the ratio of the Aid received (constant 2012 US$) in Other small states in 1978 to that in 1980?
Keep it short and to the point. 0.96. What is the ratio of the Aid received (constant 2012 US$) of Central African Republic in 1978 to that in 1980?
Keep it short and to the point. 0.6. What is the ratio of the Aid received (constant 2012 US$) in Somalia in 1978 to that in 1980?
Your answer should be very brief. 0.67. What is the ratio of the Aid received (constant 2012 US$) of Other small states in 1978 to that in 1981?
Make the answer very short. 0.91. What is the ratio of the Aid received (constant 2012 US$) in Central African Republic in 1978 to that in 1981?
Your answer should be compact. 0.57. What is the ratio of the Aid received (constant 2012 US$) of Somalia in 1978 to that in 1981?
Your answer should be compact. 0.79. What is the ratio of the Aid received (constant 2012 US$) of Other small states in 1978 to that in 1982?
Offer a terse response. 0.93. What is the ratio of the Aid received (constant 2012 US$) of Central African Republic in 1978 to that in 1982?
Provide a short and direct response. 0.61. What is the ratio of the Aid received (constant 2012 US$) of Somalia in 1978 to that in 1982?
Your answer should be compact. 0.62. What is the ratio of the Aid received (constant 2012 US$) of Other small states in 1978 to that in 1983?
Ensure brevity in your answer.  0.87. What is the ratio of the Aid received (constant 2012 US$) in Central African Republic in 1978 to that in 1983?
Provide a succinct answer. 0.57. What is the ratio of the Aid received (constant 2012 US$) of Somalia in 1978 to that in 1983?
Offer a very short reply. 0.86. What is the ratio of the Aid received (constant 2012 US$) of Other small states in 1979 to that in 1980?
Provide a succinct answer. 0.79. What is the ratio of the Aid received (constant 2012 US$) in Central African Republic in 1979 to that in 1980?
Provide a succinct answer. 0.85. What is the ratio of the Aid received (constant 2012 US$) of Somalia in 1979 to that in 1980?
Give a very brief answer. 0.62. What is the ratio of the Aid received (constant 2012 US$) in Other small states in 1979 to that in 1981?
Keep it short and to the point. 0.75. What is the ratio of the Aid received (constant 2012 US$) in Central African Republic in 1979 to that in 1981?
Give a very brief answer. 0.82. What is the ratio of the Aid received (constant 2012 US$) in Somalia in 1979 to that in 1981?
Offer a terse response. 0.74. What is the ratio of the Aid received (constant 2012 US$) in Other small states in 1979 to that in 1982?
Your response must be concise. 0.76. What is the ratio of the Aid received (constant 2012 US$) of Central African Republic in 1979 to that in 1982?
Offer a terse response. 0.88. What is the ratio of the Aid received (constant 2012 US$) in Somalia in 1979 to that in 1982?
Ensure brevity in your answer.  0.58. What is the ratio of the Aid received (constant 2012 US$) of Other small states in 1979 to that in 1983?
Provide a short and direct response. 0.71. What is the ratio of the Aid received (constant 2012 US$) in Central African Republic in 1979 to that in 1983?
Offer a very short reply. 0.82. What is the ratio of the Aid received (constant 2012 US$) of Somalia in 1979 to that in 1983?
Keep it short and to the point. 0.81. What is the ratio of the Aid received (constant 2012 US$) of Other small states in 1980 to that in 1981?
Offer a terse response. 0.94. What is the ratio of the Aid received (constant 2012 US$) of Central African Republic in 1980 to that in 1981?
Keep it short and to the point. 0.96. What is the ratio of the Aid received (constant 2012 US$) in Somalia in 1980 to that in 1981?
Give a very brief answer. 1.19. What is the ratio of the Aid received (constant 2012 US$) in Other small states in 1980 to that in 1982?
Your answer should be compact. 0.96. What is the ratio of the Aid received (constant 2012 US$) in Central African Republic in 1980 to that in 1982?
Your answer should be compact. 1.03. What is the ratio of the Aid received (constant 2012 US$) of Somalia in 1980 to that in 1982?
Ensure brevity in your answer.  0.93. What is the ratio of the Aid received (constant 2012 US$) in Other small states in 1980 to that in 1983?
Give a very brief answer. 0.9. What is the ratio of the Aid received (constant 2012 US$) of Central African Republic in 1980 to that in 1983?
Give a very brief answer. 0.96. What is the ratio of the Aid received (constant 2012 US$) of Somalia in 1980 to that in 1983?
Provide a short and direct response. 1.29. What is the ratio of the Aid received (constant 2012 US$) of Other small states in 1981 to that in 1982?
Offer a terse response. 1.02. What is the ratio of the Aid received (constant 2012 US$) of Central African Republic in 1981 to that in 1982?
Offer a terse response. 1.07. What is the ratio of the Aid received (constant 2012 US$) in Somalia in 1981 to that in 1982?
Ensure brevity in your answer.  0.78. What is the ratio of the Aid received (constant 2012 US$) of Other small states in 1981 to that in 1983?
Your answer should be compact. 0.96. What is the ratio of the Aid received (constant 2012 US$) of Somalia in 1981 to that in 1983?
Give a very brief answer. 1.09. What is the ratio of the Aid received (constant 2012 US$) of Other small states in 1982 to that in 1983?
Your answer should be very brief. 0.94. What is the ratio of the Aid received (constant 2012 US$) in Central African Republic in 1982 to that in 1983?
Provide a succinct answer. 0.93. What is the ratio of the Aid received (constant 2012 US$) in Somalia in 1982 to that in 1983?
Your answer should be compact. 1.39. What is the difference between the highest and the second highest Aid received (constant 2012 US$) in Other small states?
Ensure brevity in your answer.  7.74e+07. What is the difference between the highest and the second highest Aid received (constant 2012 US$) of Central African Republic?
Offer a terse response. 5.30e+05. What is the difference between the highest and the second highest Aid received (constant 2012 US$) in Somalia?
Your answer should be very brief. 9.18e+07. What is the difference between the highest and the lowest Aid received (constant 2012 US$) of Other small states?
Your answer should be compact. 7.39e+08. What is the difference between the highest and the lowest Aid received (constant 2012 US$) of Central African Republic?
Offer a very short reply. 1.13e+08. What is the difference between the highest and the lowest Aid received (constant 2012 US$) of Somalia?
Offer a very short reply. 8.66e+08. 